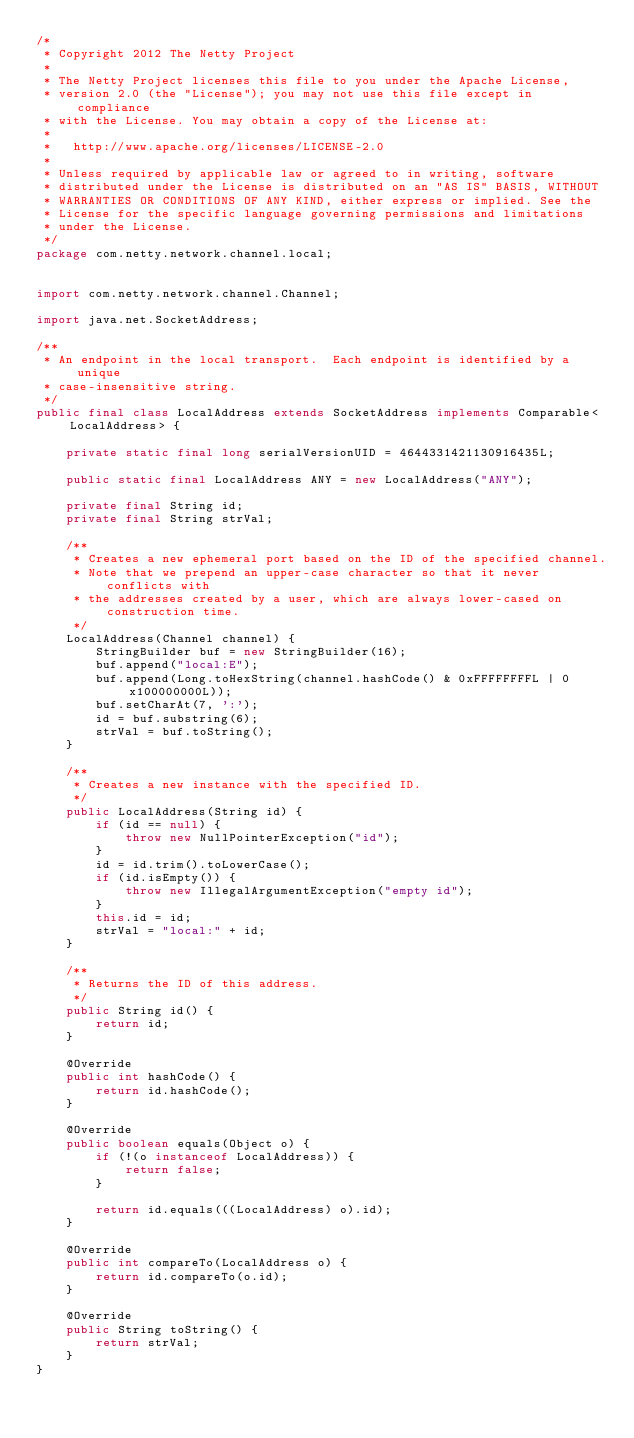<code> <loc_0><loc_0><loc_500><loc_500><_Java_>/*
 * Copyright 2012 The Netty Project
 *
 * The Netty Project licenses this file to you under the Apache License,
 * version 2.0 (the "License"); you may not use this file except in compliance
 * with the License. You may obtain a copy of the License at:
 *
 *   http://www.apache.org/licenses/LICENSE-2.0
 *
 * Unless required by applicable law or agreed to in writing, software
 * distributed under the License is distributed on an "AS IS" BASIS, WITHOUT
 * WARRANTIES OR CONDITIONS OF ANY KIND, either express or implied. See the
 * License for the specific language governing permissions and limitations
 * under the License.
 */
package com.netty.network.channel.local;


import com.netty.network.channel.Channel;

import java.net.SocketAddress;

/**
 * An endpoint in the local transport.  Each endpoint is identified by a unique
 * case-insensitive string.
 */
public final class LocalAddress extends SocketAddress implements Comparable<LocalAddress> {

    private static final long serialVersionUID = 4644331421130916435L;

    public static final LocalAddress ANY = new LocalAddress("ANY");

    private final String id;
    private final String strVal;

    /**
     * Creates a new ephemeral port based on the ID of the specified channel.
     * Note that we prepend an upper-case character so that it never conflicts with
     * the addresses created by a user, which are always lower-cased on construction time.
     */
    LocalAddress(Channel channel) {
        StringBuilder buf = new StringBuilder(16);
        buf.append("local:E");
        buf.append(Long.toHexString(channel.hashCode() & 0xFFFFFFFFL | 0x100000000L));
        buf.setCharAt(7, ':');
        id = buf.substring(6);
        strVal = buf.toString();
    }

    /**
     * Creates a new instance with the specified ID.
     */
    public LocalAddress(String id) {
        if (id == null) {
            throw new NullPointerException("id");
        }
        id = id.trim().toLowerCase();
        if (id.isEmpty()) {
            throw new IllegalArgumentException("empty id");
        }
        this.id = id;
        strVal = "local:" + id;
    }

    /**
     * Returns the ID of this address.
     */
    public String id() {
        return id;
    }

    @Override
    public int hashCode() {
        return id.hashCode();
    }

    @Override
    public boolean equals(Object o) {
        if (!(o instanceof LocalAddress)) {
            return false;
        }

        return id.equals(((LocalAddress) o).id);
    }

    @Override
    public int compareTo(LocalAddress o) {
        return id.compareTo(o.id);
    }

    @Override
    public String toString() {
        return strVal;
    }
}
</code> 